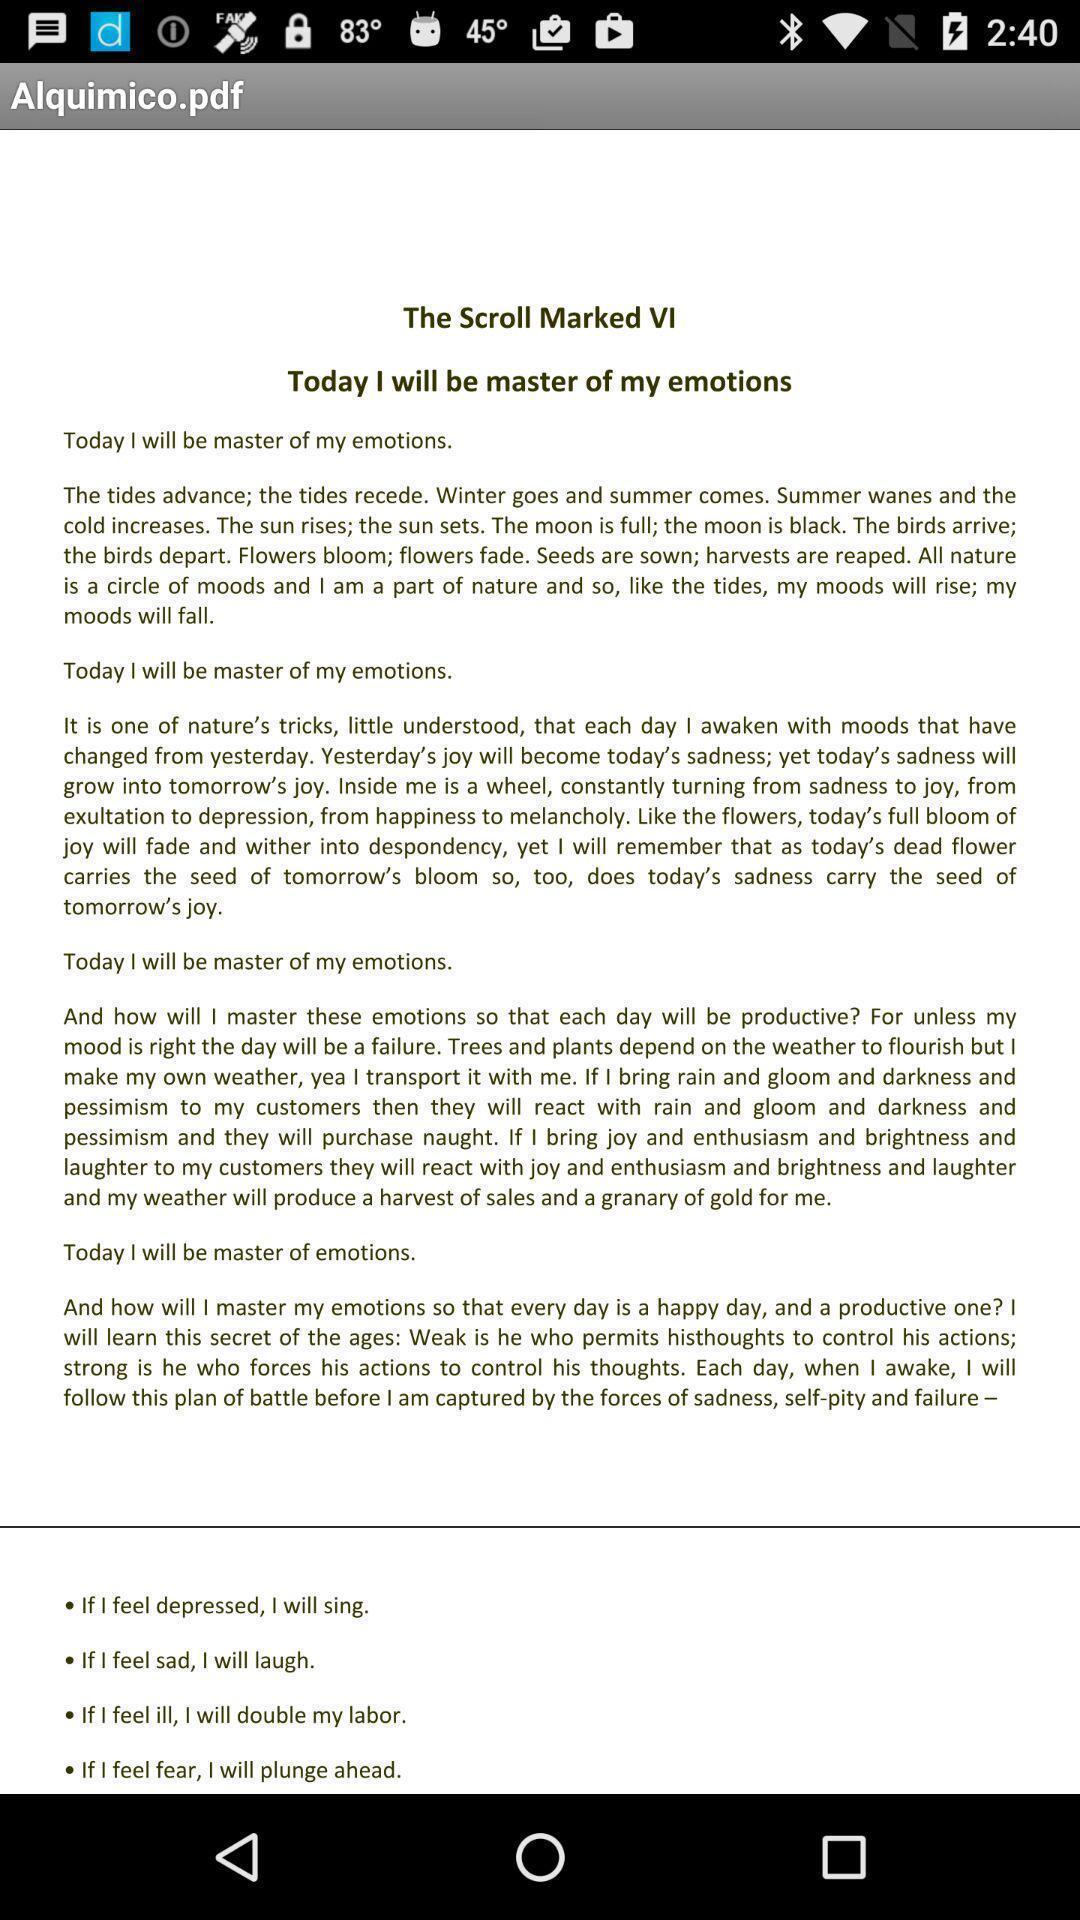Tell me about the visual elements in this screen capture. Page is showing a pdf. 